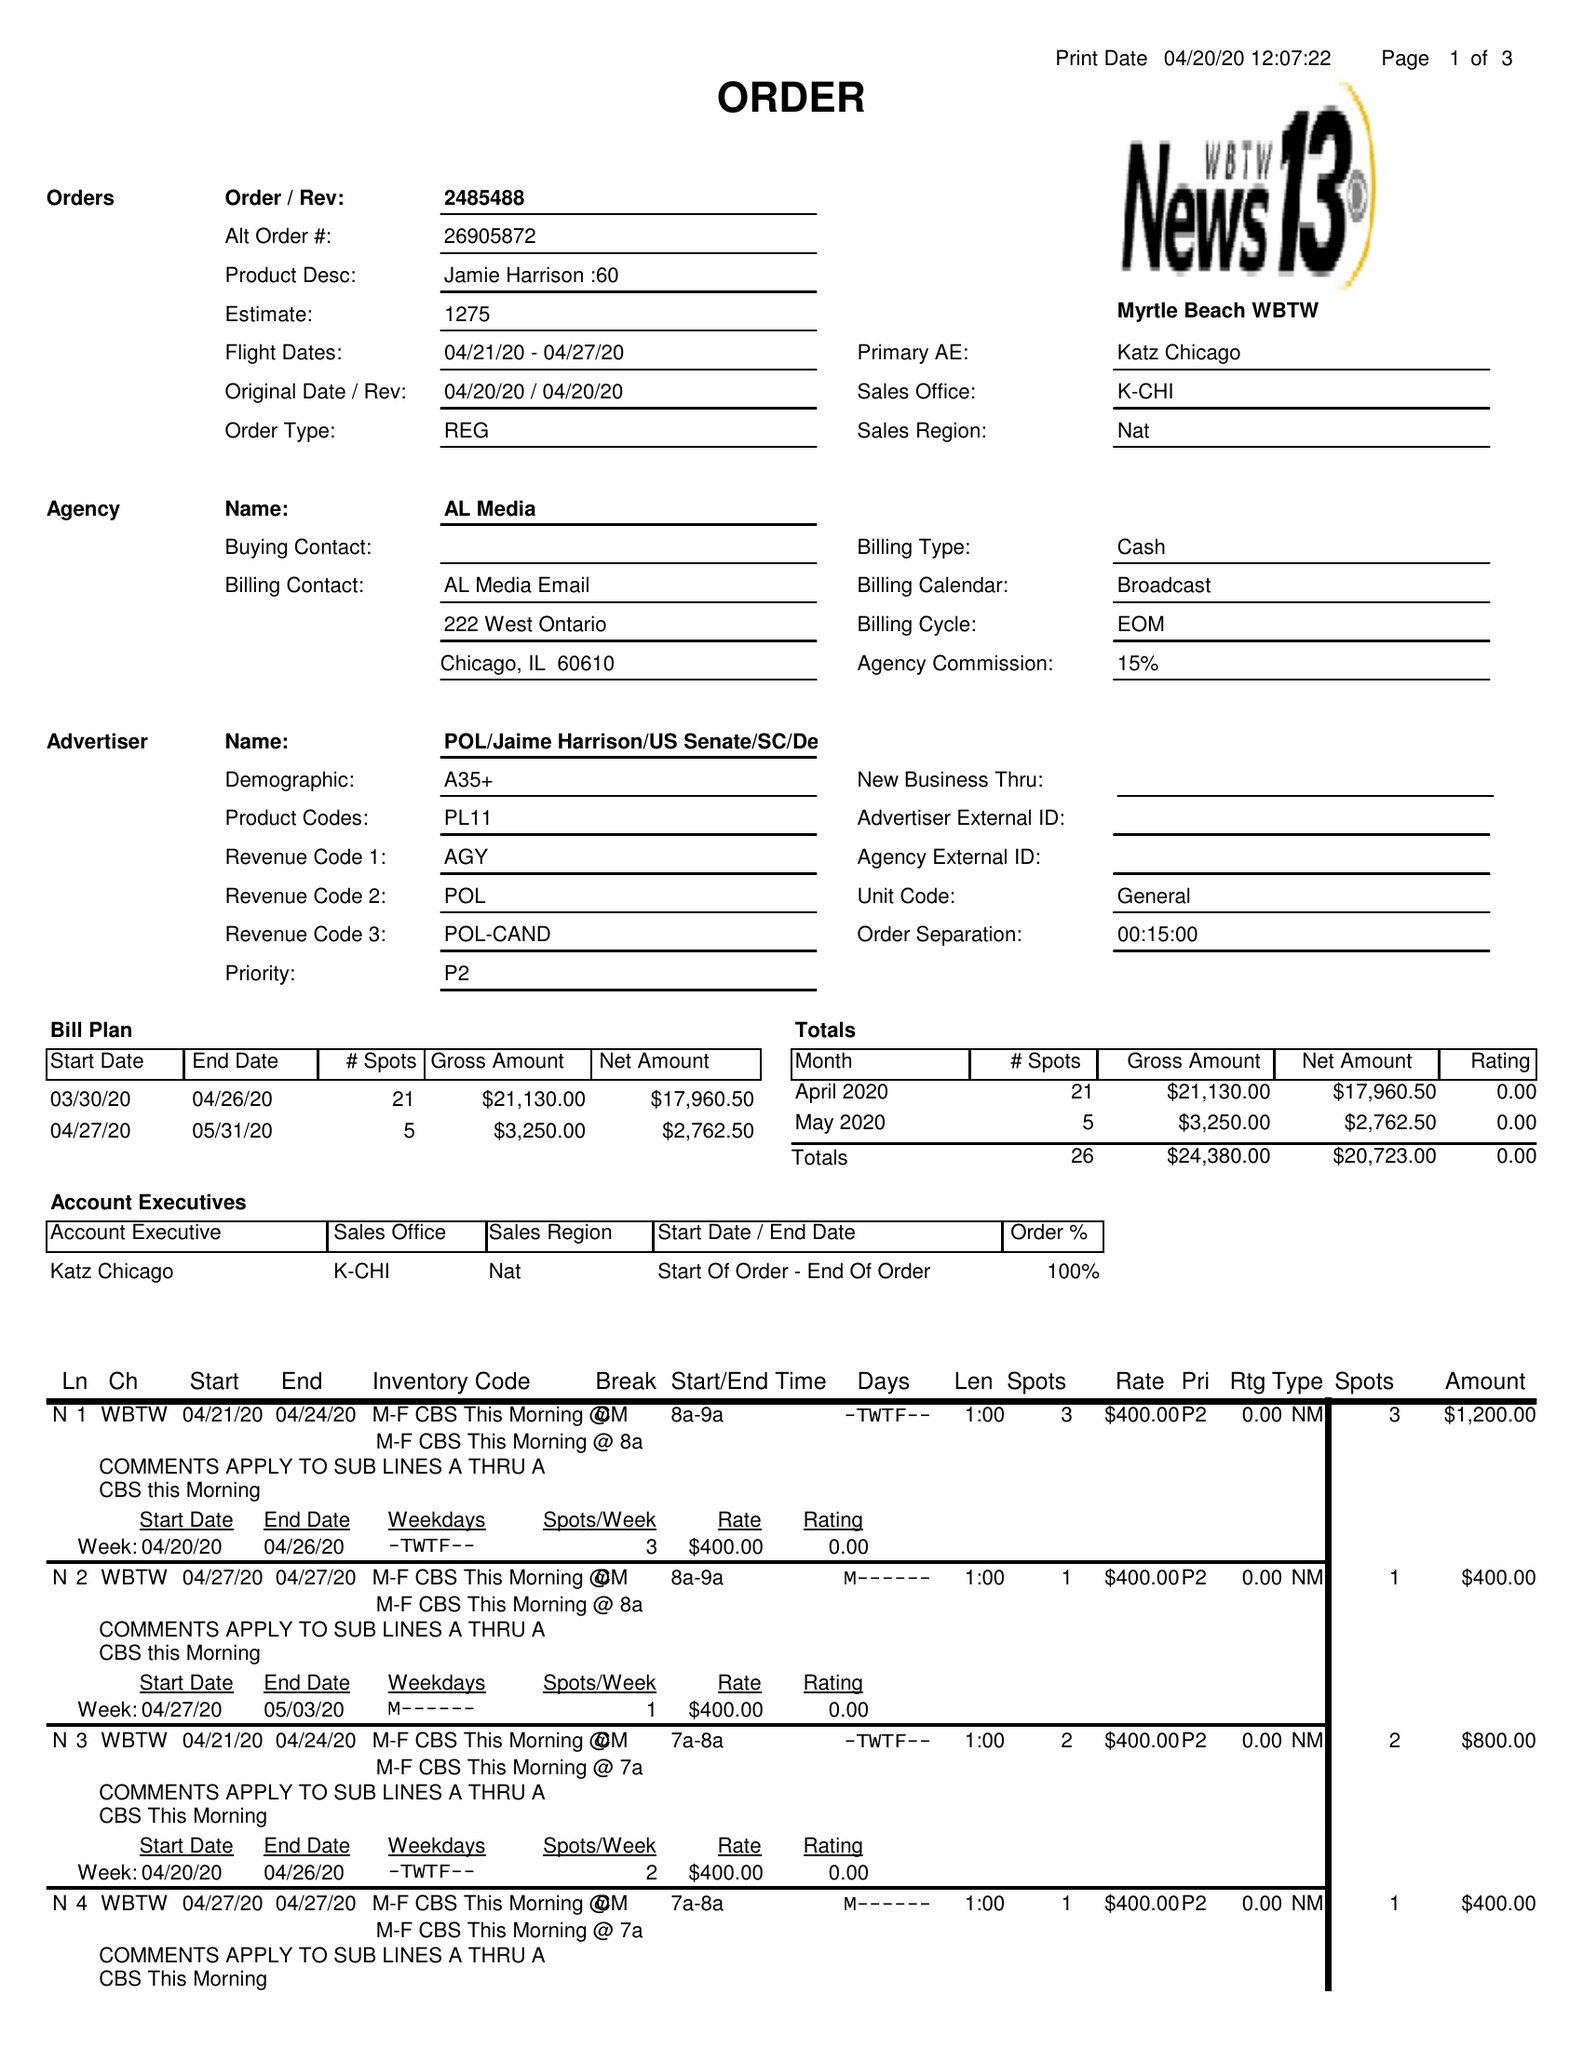What is the value for the gross_amount?
Answer the question using a single word or phrase. 24380.00 